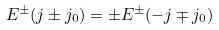<formula> <loc_0><loc_0><loc_500><loc_500>E ^ { \pm } ( j \pm j _ { 0 } ) = \pm E ^ { \pm } ( - j \mp j _ { 0 } )</formula> 